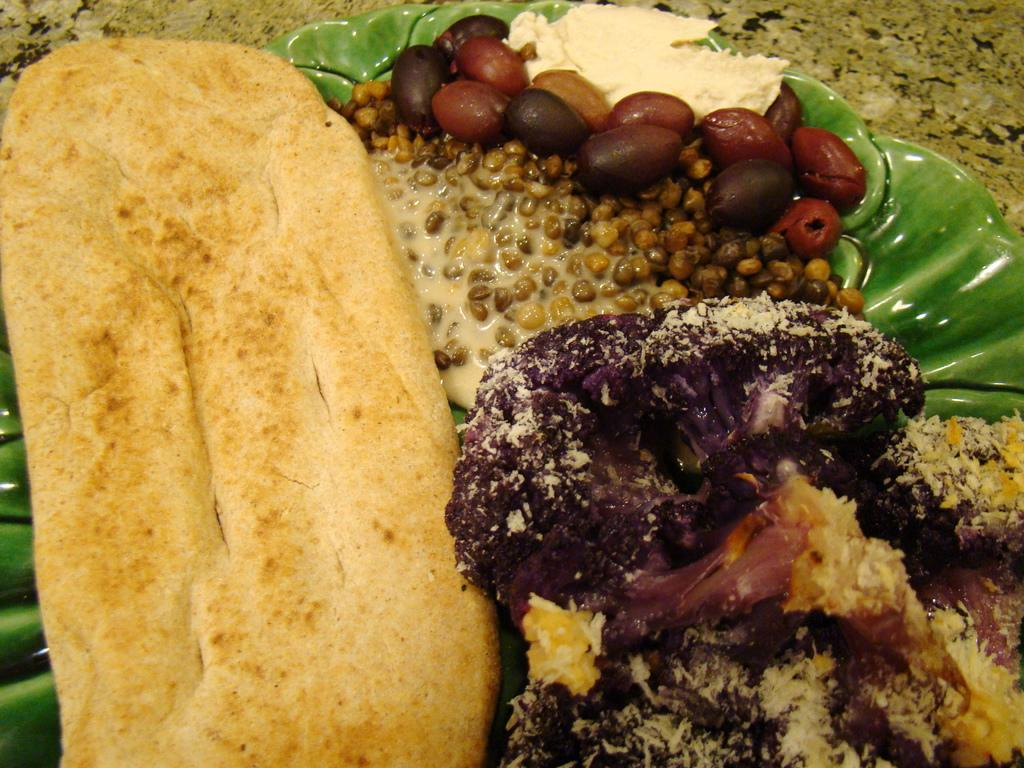What is on the green plate in the image? There are food items on a green plate in the image. Can you describe the surface visible at the top of the image? The top of the image shows a surface, but no specific details are provided about its material or appearance. What type of roll is being used to clean the blood on the surface in the image? There is no roll or blood present in the image; it only shows food items on a green plate and a surface at the top. 